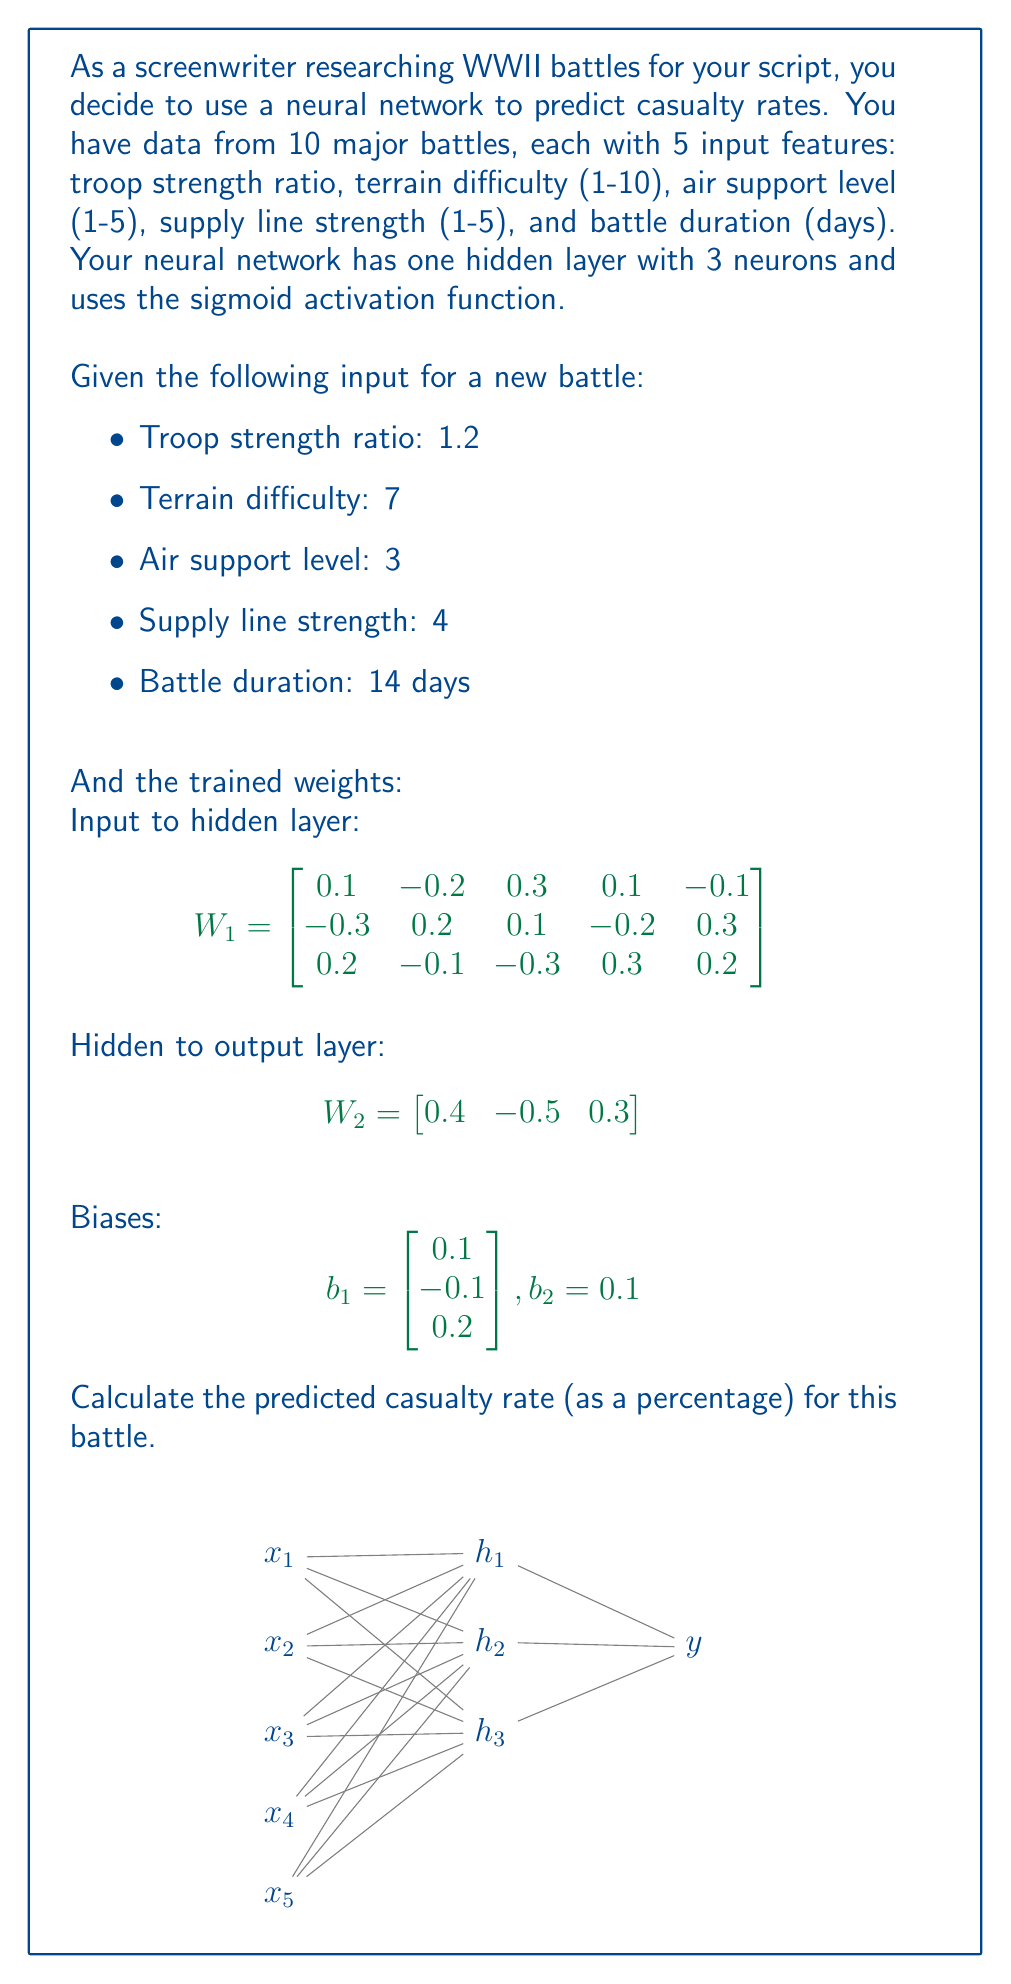What is the answer to this math problem? Let's solve this step-by-step:

1) First, we need to calculate the output of the hidden layer. For each neuron in the hidden layer:

   $$h_i = \sigma(W_1[i] \cdot X + b_1[i])$$

   where $\sigma(x) = \frac{1}{1 + e^{-x}}$ is the sigmoid function, and $X$ is our input vector.

2) Let's calculate the dot product for each hidden neuron:

   $$\begin{align}
   z_1 &= 0.1(1.2) + (-0.2)(7) + 0.3(3) + 0.1(4) + (-0.1)(14) + 0.1 = -1.5 \\
   z_2 &= (-0.3)(1.2) + 0.2(7) + 0.1(3) + (-0.2)(4) + 0.3(14) - 0.1 = 5.04 \\
   z_3 &= 0.2(1.2) + (-0.1)(7) + (-0.3)(3) + 0.3(4) + 0.2(14) + 0.2 = 3.34
   \end{align}$$

3) Now apply the sigmoid function:

   $$\begin{align}
   h_1 &= \sigma(-1.5) = 0.1824 \\
   h_2 &= \sigma(5.04) = 0.9936 \\
   h_3 &= \sigma(3.34) = 0.9658
   \end{align}$$

4) For the output layer, we calculate:

   $$y = \sigma(W_2 \cdot H + b_2)$$

   where $H$ is the vector of hidden layer outputs.

5) Let's calculate the dot product:

   $$0.4(0.1824) + (-0.5)(0.9936) + 0.3(0.9658) + 0.1 = -0.0871$$

6) Apply the sigmoid function:

   $$y = \sigma(-0.0871) = 0.4782$$

7) This output represents the predicted casualty rate as a probability. To convert to a percentage, we multiply by 100:

   Casualty rate = $0.4782 \times 100\% = 47.82\%$
Answer: 47.82% 